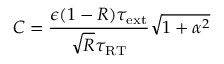<formula> <loc_0><loc_0><loc_500><loc_500>C = \frac { \epsilon ( 1 - R ) \tau _ { e x t } } { \sqrt { R } \tau _ { R T } } \sqrt { 1 + \alpha ^ { 2 } }</formula> 